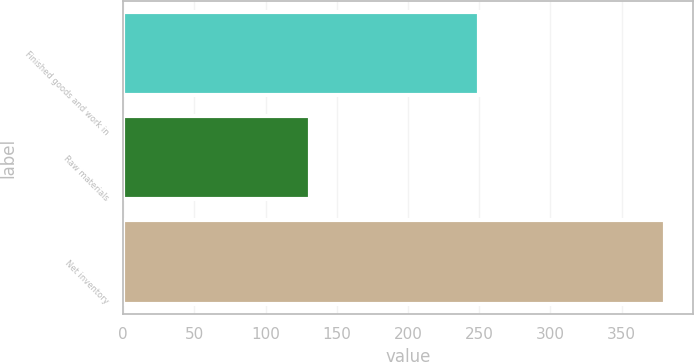Convert chart to OTSL. <chart><loc_0><loc_0><loc_500><loc_500><bar_chart><fcel>Finished goods and work in<fcel>Raw materials<fcel>Net inventory<nl><fcel>249.7<fcel>131.1<fcel>380.8<nl></chart> 